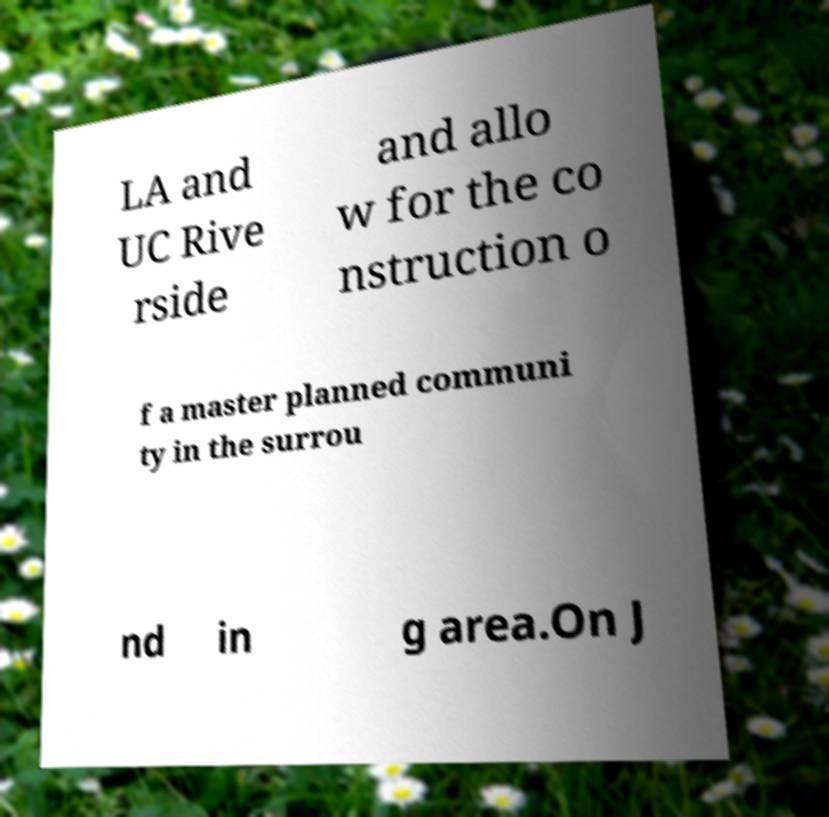There's text embedded in this image that I need extracted. Can you transcribe it verbatim? LA and UC Rive rside and allo w for the co nstruction o f a master planned communi ty in the surrou nd in g area.On J 